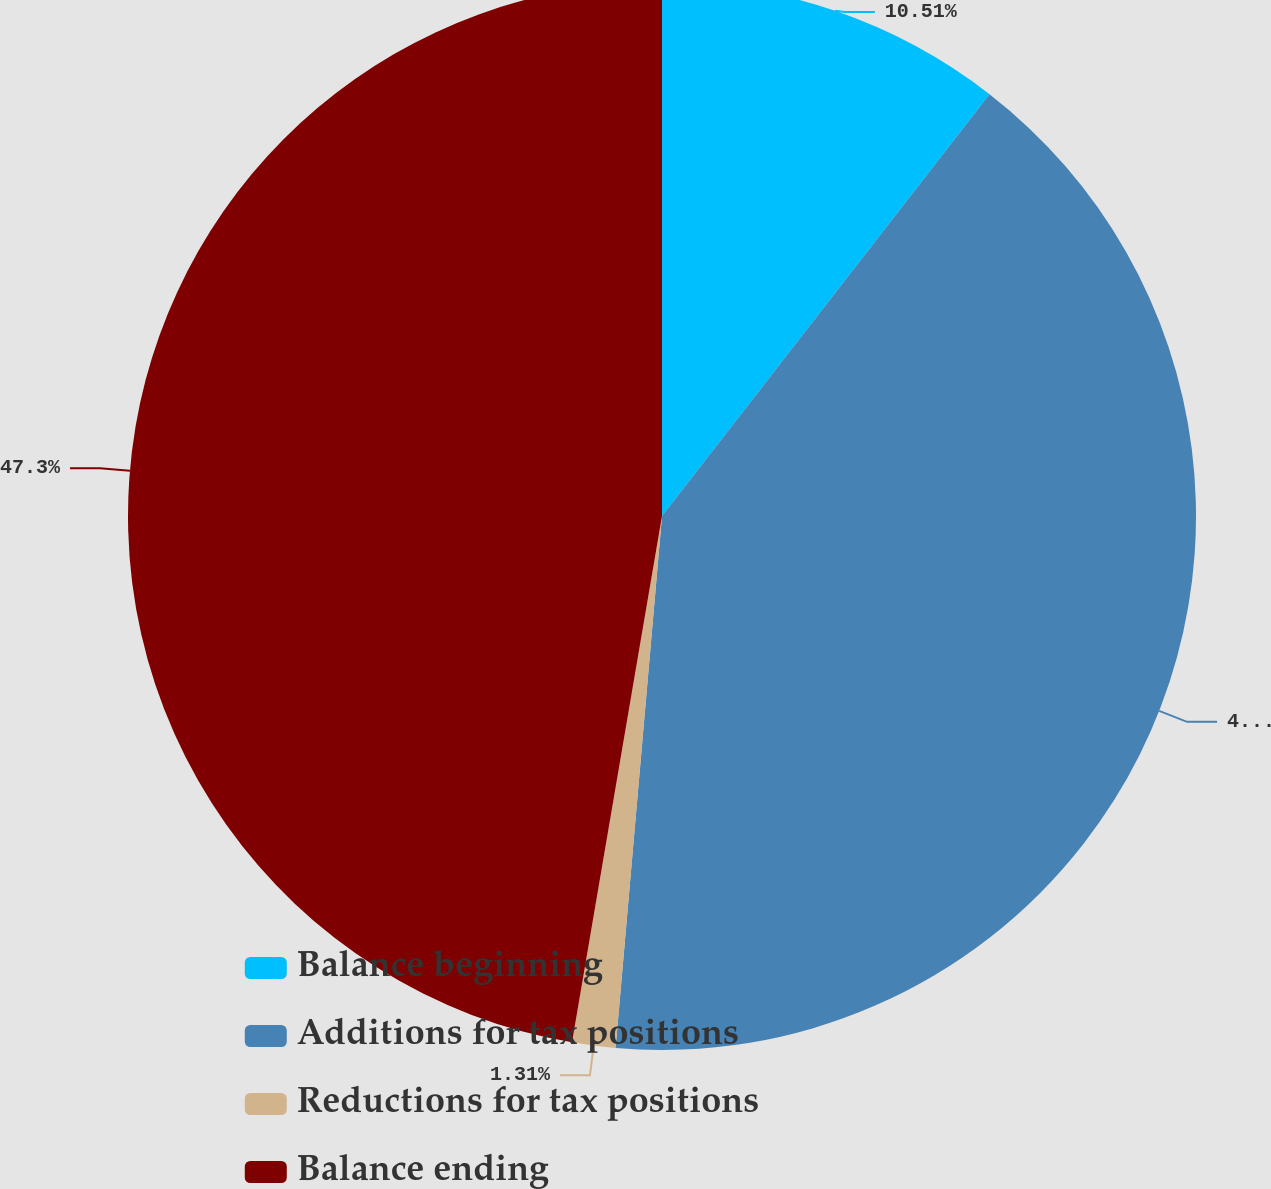Convert chart. <chart><loc_0><loc_0><loc_500><loc_500><pie_chart><fcel>Balance beginning<fcel>Additions for tax positions<fcel>Reductions for tax positions<fcel>Balance ending<nl><fcel>10.51%<fcel>40.88%<fcel>1.31%<fcel>47.31%<nl></chart> 